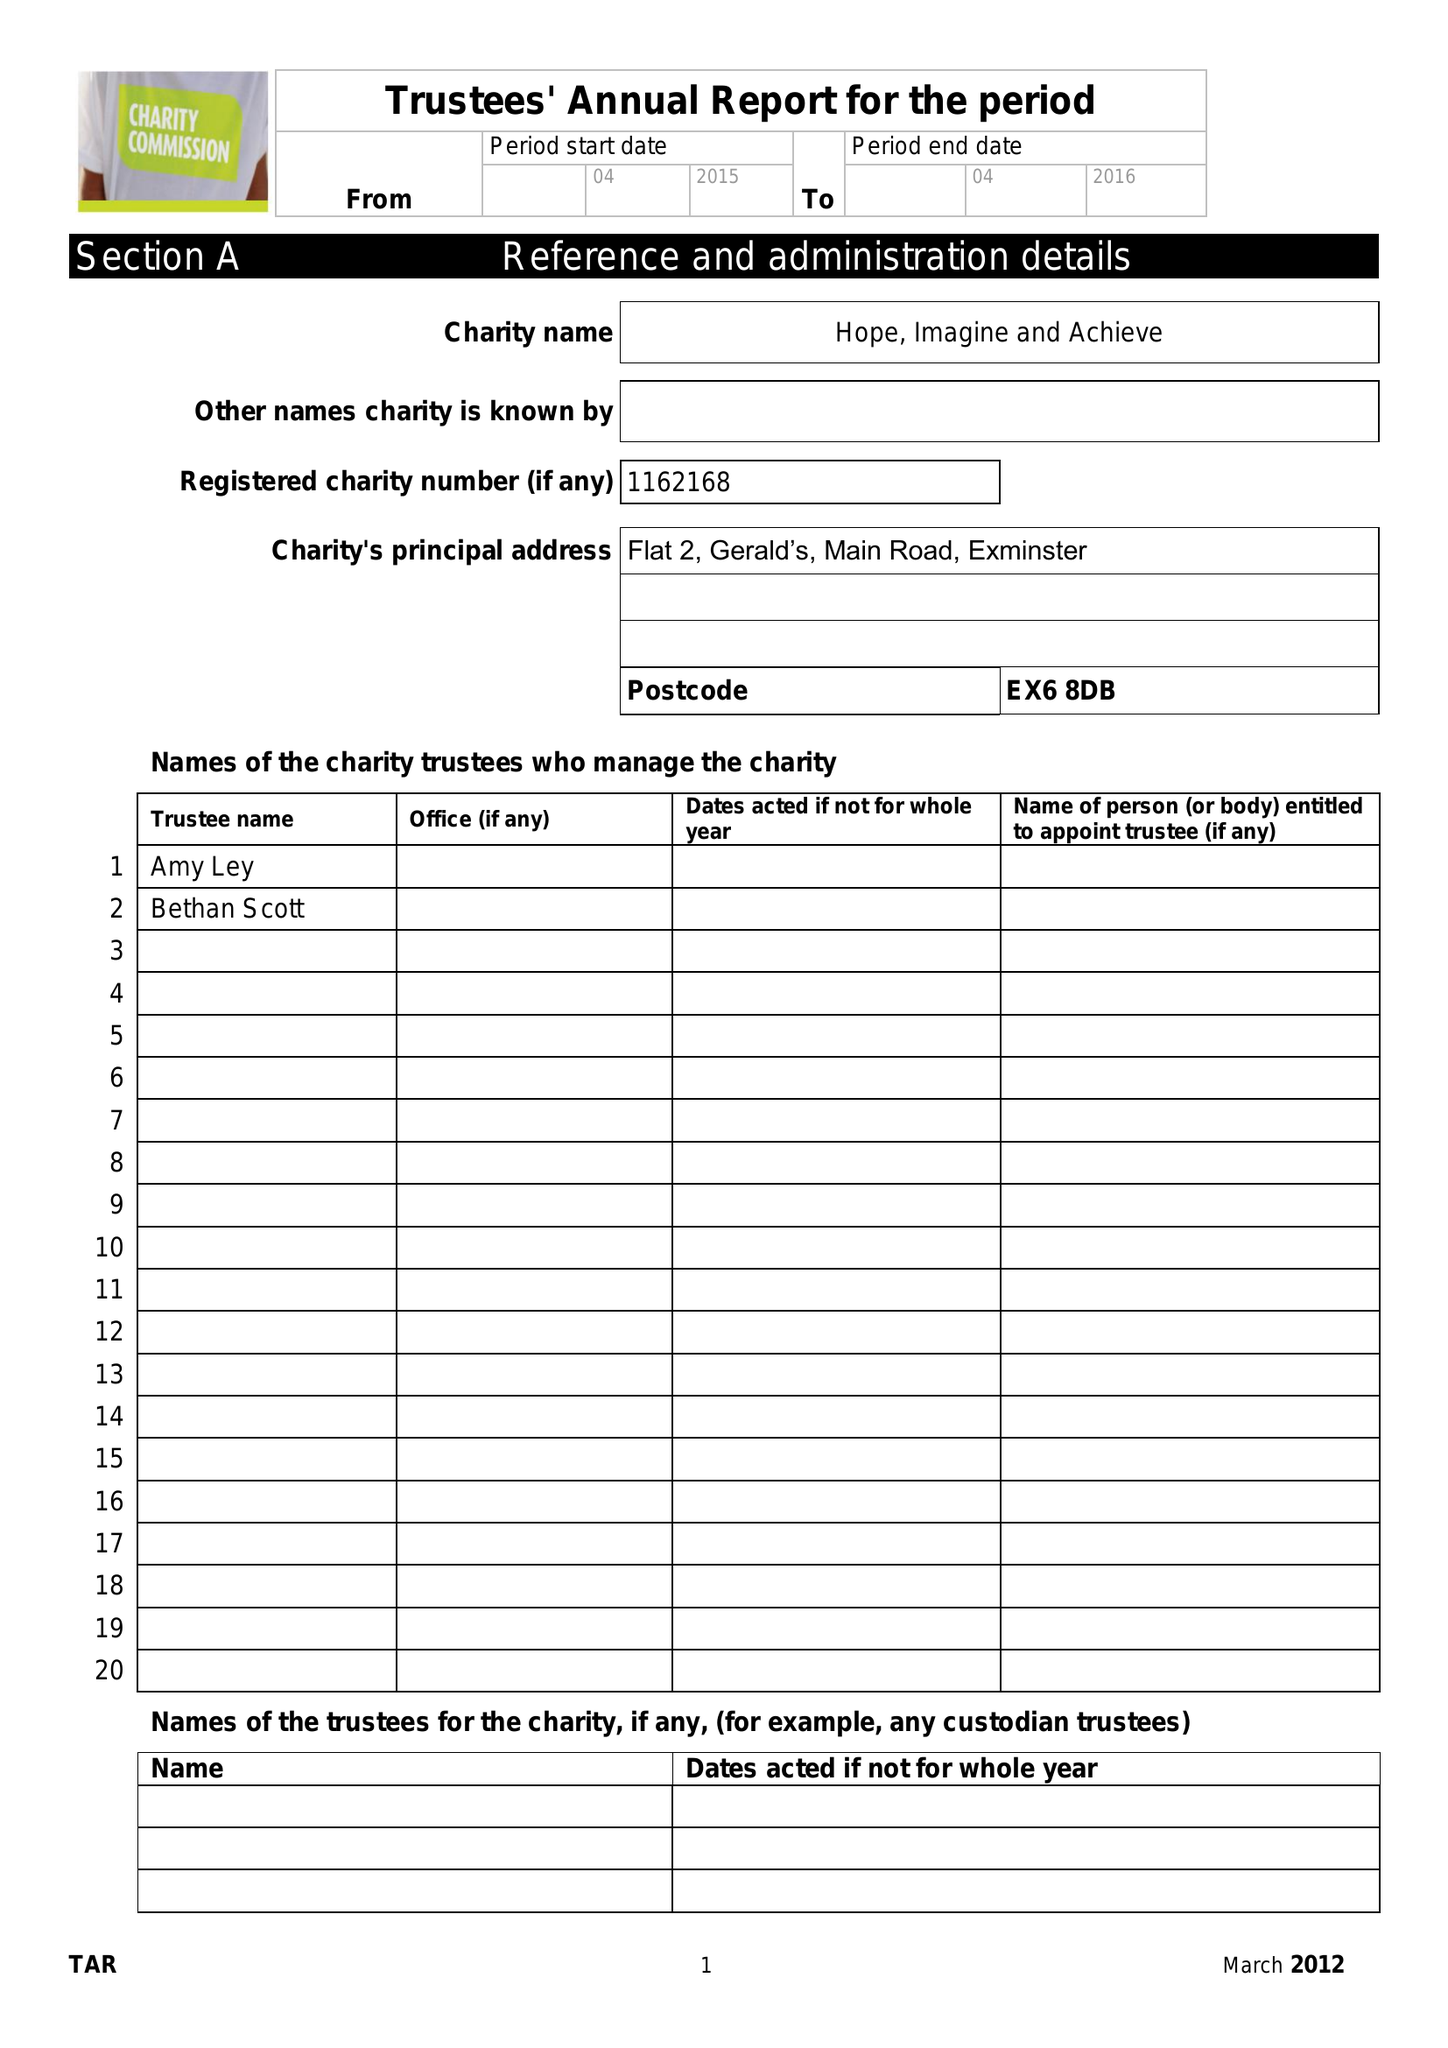What is the value for the spending_annually_in_british_pounds?
Answer the question using a single word or phrase. None 